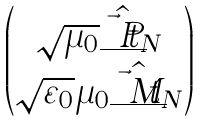Convert formula to latex. <formula><loc_0><loc_0><loc_500><loc_500>\begin{pmatrix} \sqrt { \mu _ { 0 } } \hat { \underline { \vec { t } { P } } } _ { N } \\ \sqrt { \varepsilon _ { 0 } } \mu _ { 0 } \hat { \underline { \vec { t } { M } } } _ { N } \end{pmatrix}</formula> 